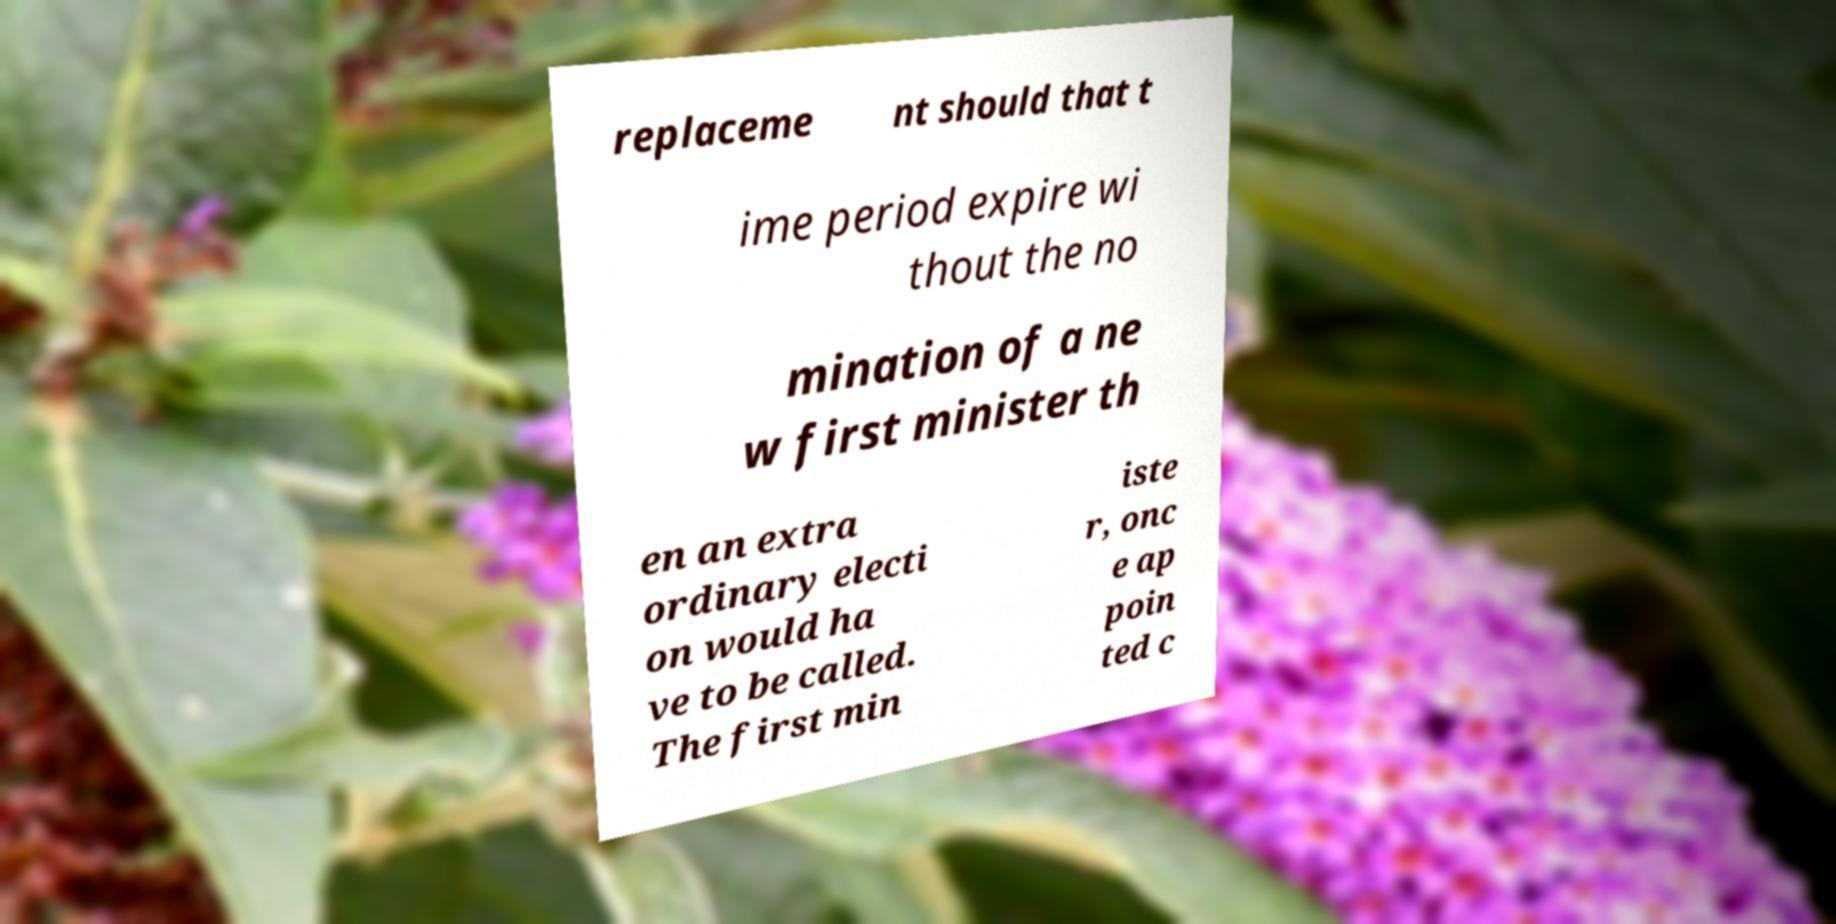Could you extract and type out the text from this image? replaceme nt should that t ime period expire wi thout the no mination of a ne w first minister th en an extra ordinary electi on would ha ve to be called. The first min iste r, onc e ap poin ted c 